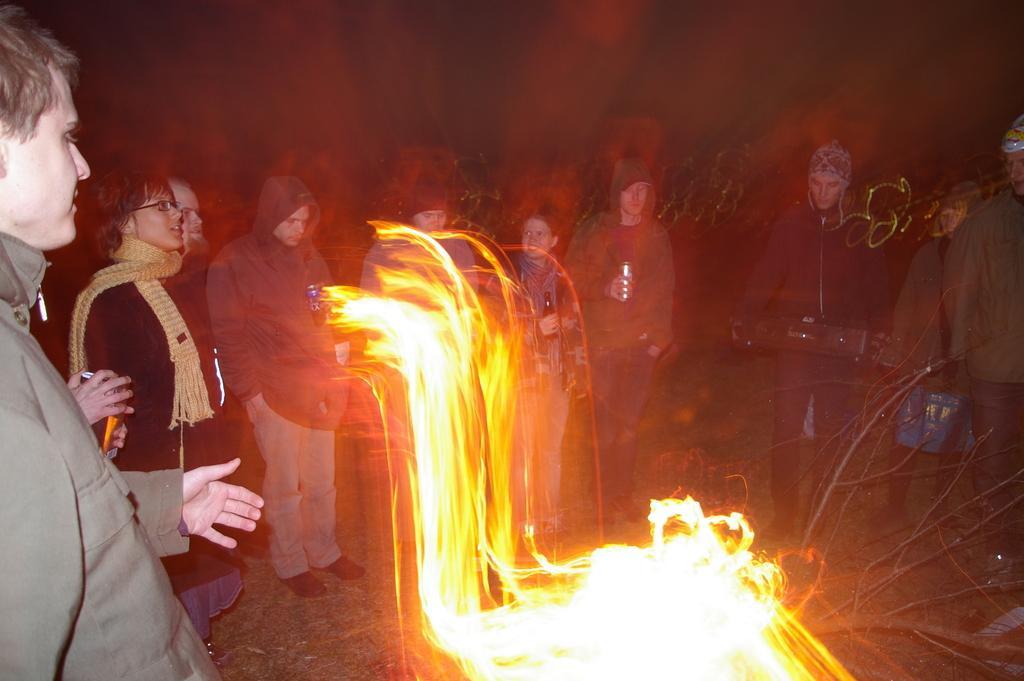How would you summarize this image in a sentence or two? In the center of the picture there are flames. On the left there are people standing. In the center of the picture there are people. In the background it is dark. 